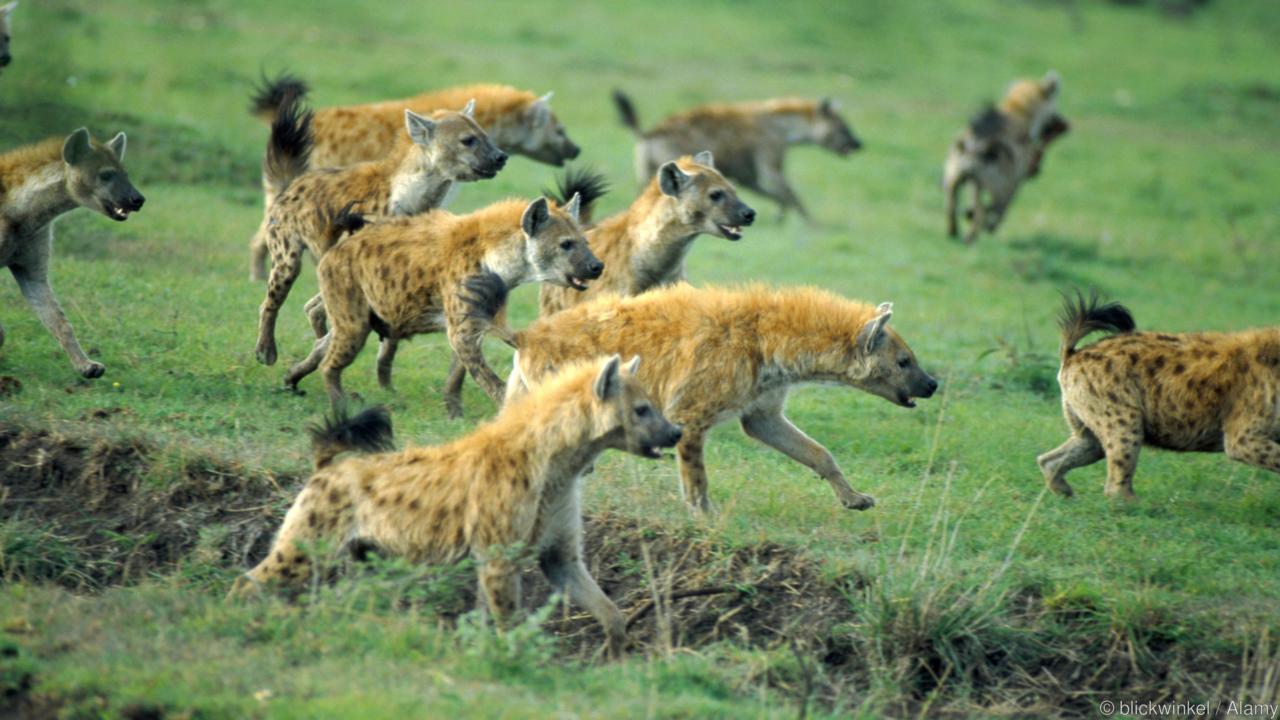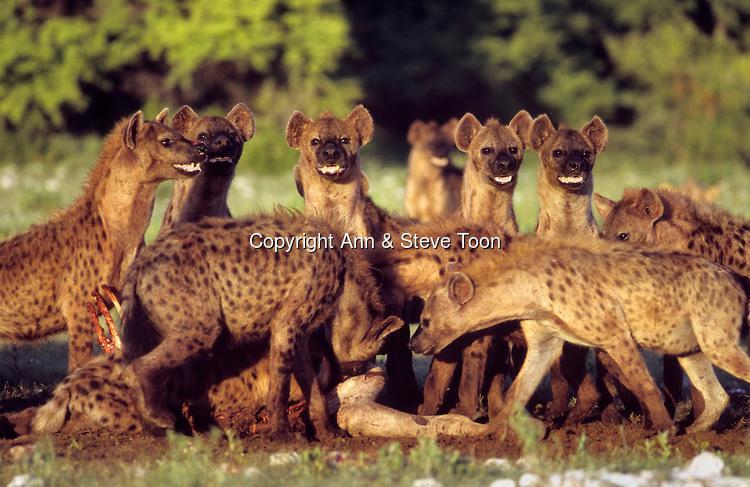The first image is the image on the left, the second image is the image on the right. Given the left and right images, does the statement "One group of animals is standing in the water." hold true? Answer yes or no. No. 